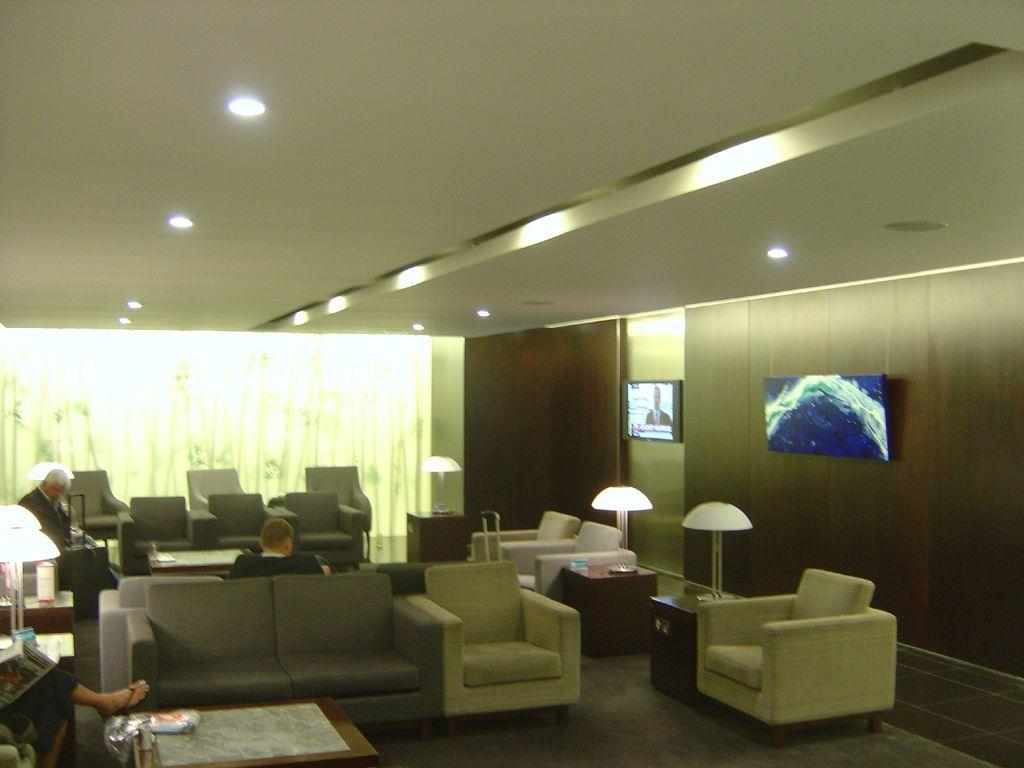What type of furniture is present in the image? There is a sofa and two chairs in the image. What are the people in the image doing? People are sitting in the chairs. Can you describe the man in the image? The man is holding a luggage bag. What is on the wall in the image? There is a TV on the wall. What type of footwear is the man wearing in the image? There is no information about the man's footwear in the image. Can you recite a verse from the book the people are reading in the image? There is no book or reading material visible in the image. 